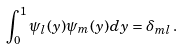Convert formula to latex. <formula><loc_0><loc_0><loc_500><loc_500>\int _ { 0 } ^ { 1 } \psi _ { l } ( y ) \psi _ { m } ( y ) d y = \delta _ { m l } \, .</formula> 